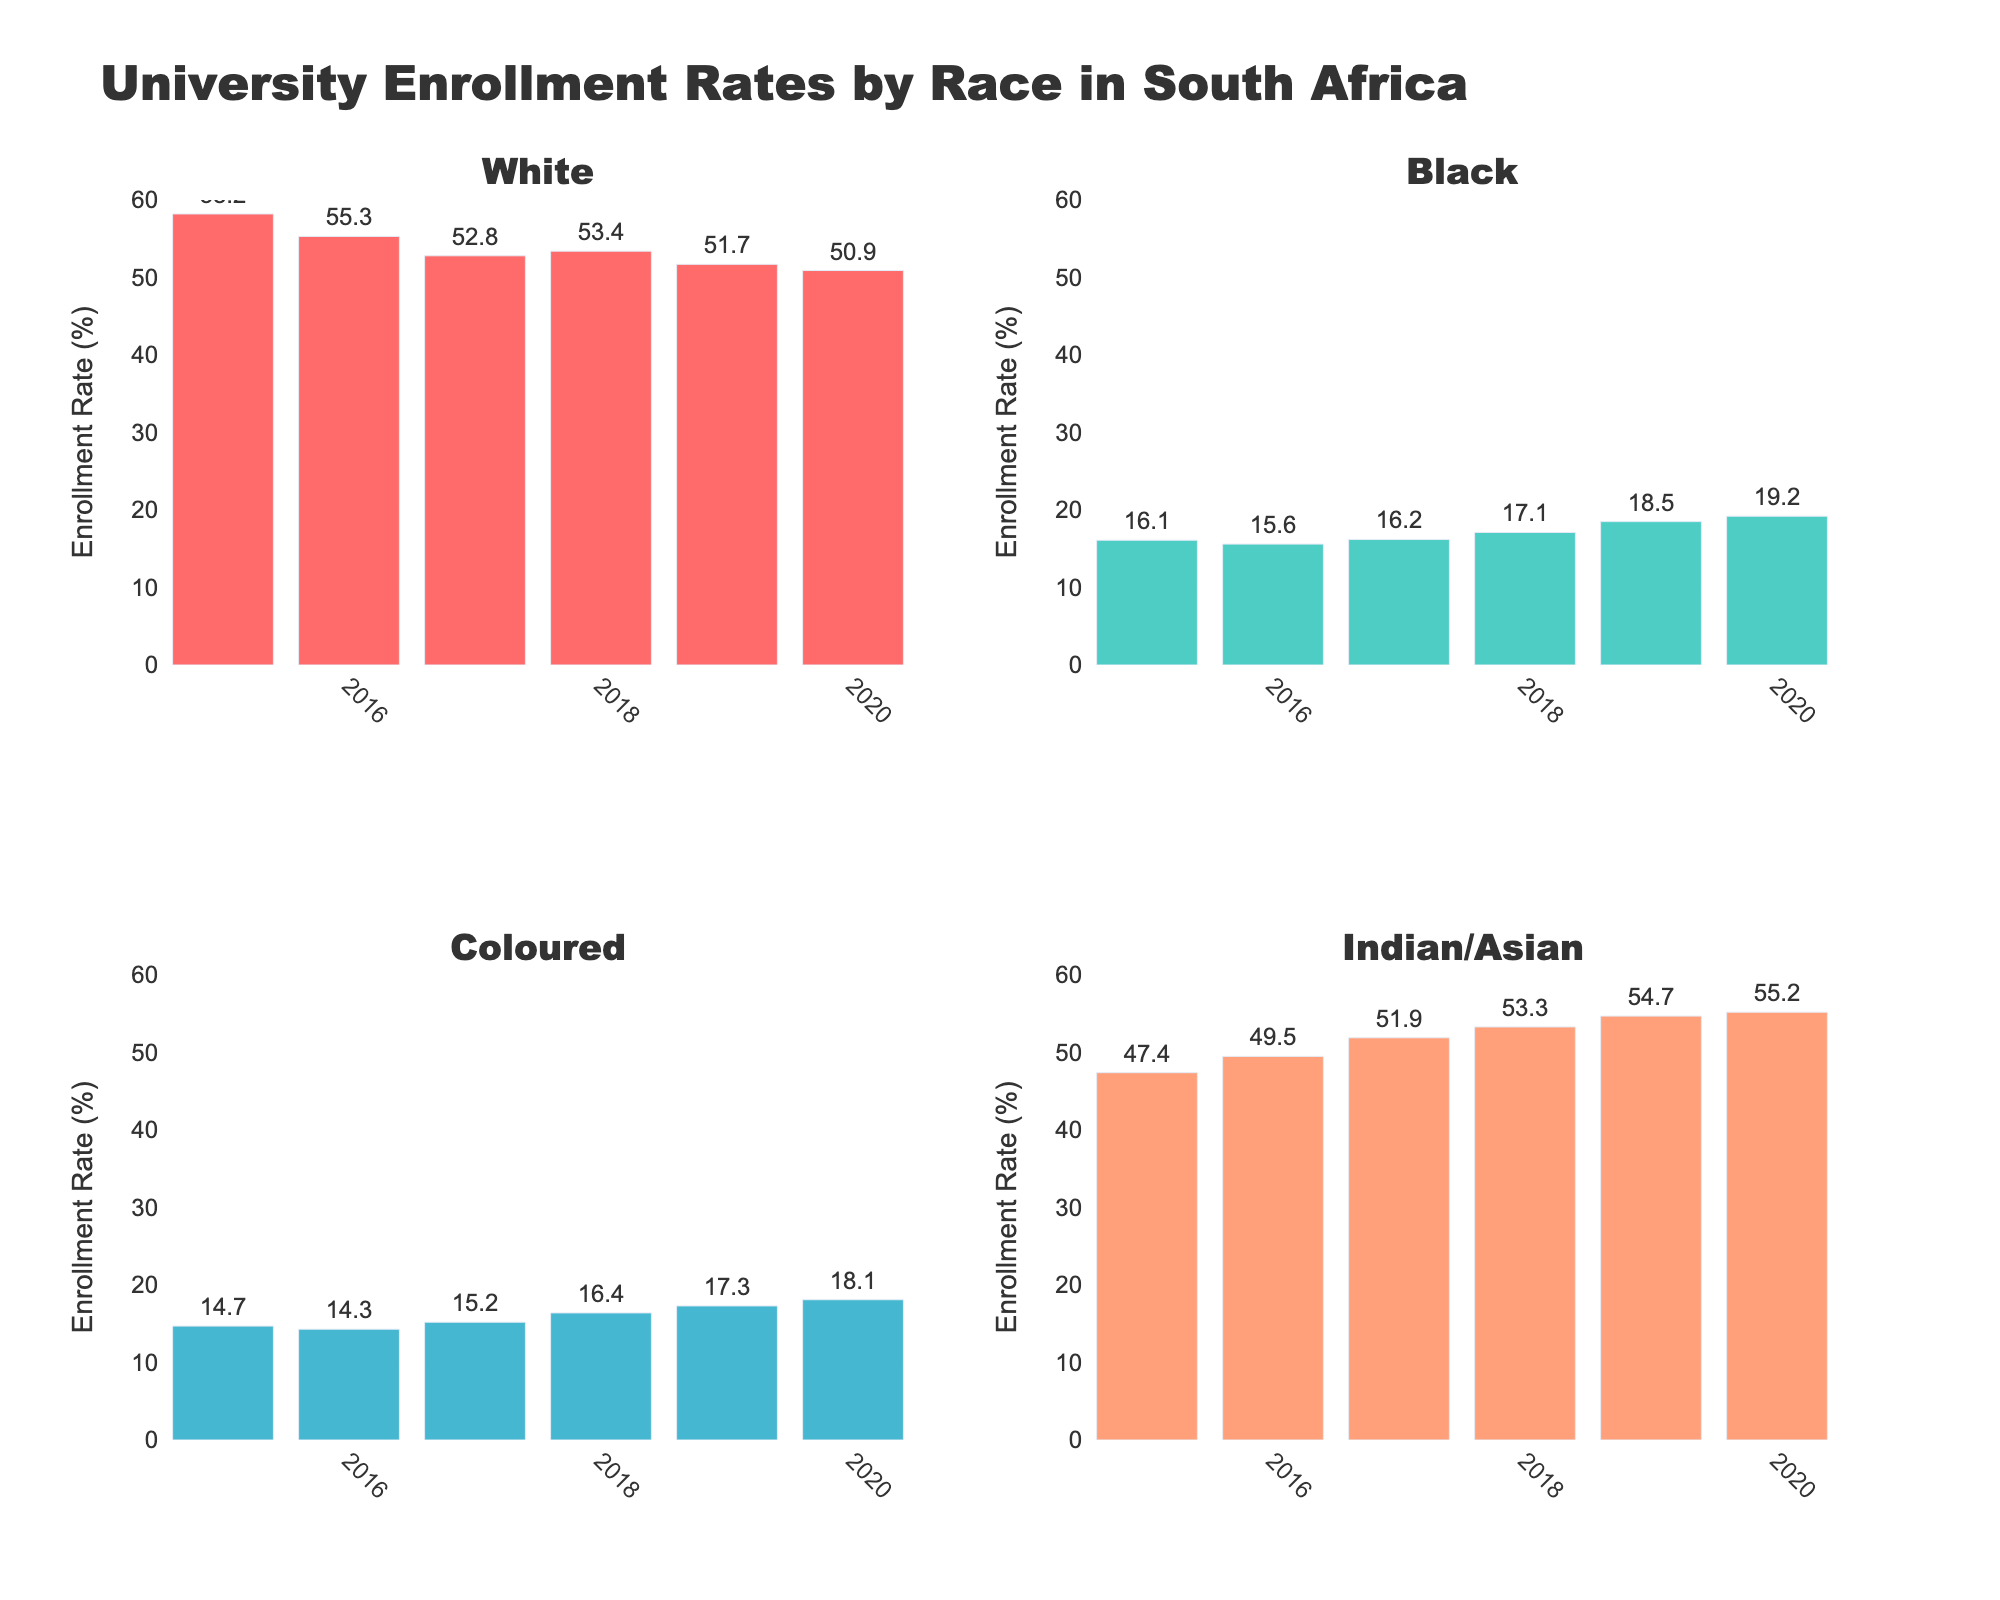What is the enrollment rate for White students in 2017? Locate the White subplot, find the bar for 2017, and read the value labeled.
Answer: 52.8% What is the trend of enrollment rates for Black students from 2015 to 2020? Observe the bars in the Black subplot from 2015 to 2020. Note the increasing height of the bars each year.
Answer: Increasing Which racial group has the highest enrollment rate in 2019? Compare the heights of the bars for each racial group in 2019. Identify the tallest bar.
Answer: Indian/Asian What is the difference in enrollment rates for Coloured students between 2018 and 2020? Identify the height of the bars for Coloured students in 2018 and 2020, and subtract the 2018 value from the 2020 value.
  18.1% (2020) - 16.4% (2018) = 1.7%
Answer: 1.7% Which racial group had the highest increase in enrollment rates from 2019 to 2020? Compare the bar heights between 2019 and 2020 for each racial group. Calculate the difference for each and identify the largest difference.
Answer: Black What is the average enrollment rate for Indian/Asian students from 2015 to 2020? Add the Indian/Asian enrollment rates for each year and divide by the number of years.
  (47.4 + 49.5 + 51.9 + 53.3 + 54.7 + 55.2) / 6 = 52.0
Answer: 52.0% Between which two consecutive years did White students see the largest drop in enrollment rate? Calculate the difference in enrollment rates for White students between each pair of consecutive years. Identify the pair with the largest decrease.
  2017-2016: 52.8% - 55.3% = -2.5%
  2016-2015: 55.3% - 58.2% = -2.9%
  2017: 52.8 - 2018: 53.4 (-0.6%); 2018: 53.4 - 2019: 51.7 (-1.7%); 2019: 51.7 - 2020: 50.9 (-0.8%)
Answer: 2016-2015 Which racial group had the most stable enrollment rates from 2015 to 2020? Compare how much the enrollment rates fluctuate for each racial group between 2015 and 2020. Look for the smallest range of values.
  White: 58.2 - 50.9 = 7.3
  Black: 19.2 - 15.6 = 3.6
  Coloured: 18.1 - 14.3 = 3.8
  Indian/Asian: 55.2 - 47.4 = 7.8
Answer: Black 